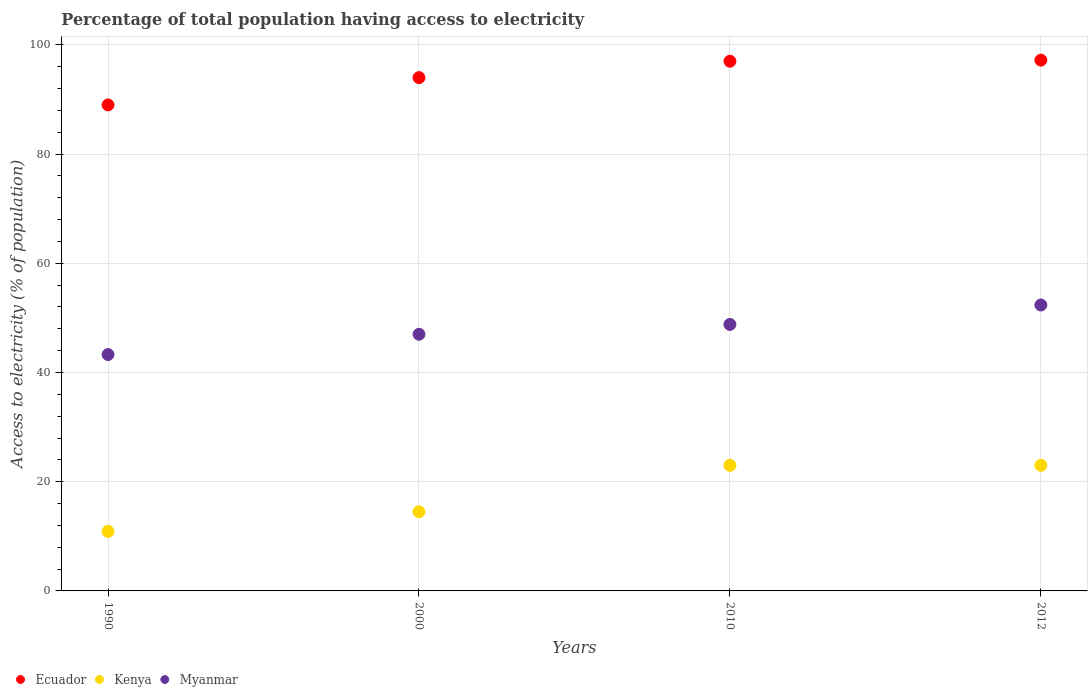How many different coloured dotlines are there?
Your response must be concise. 3. Is the number of dotlines equal to the number of legend labels?
Keep it short and to the point. Yes. What is the percentage of population that have access to electricity in Kenya in 2010?
Your answer should be compact. 23. Across all years, what is the maximum percentage of population that have access to electricity in Ecuador?
Provide a succinct answer. 97.2. Across all years, what is the minimum percentage of population that have access to electricity in Myanmar?
Give a very brief answer. 43.29. In which year was the percentage of population that have access to electricity in Myanmar minimum?
Provide a short and direct response. 1990. What is the total percentage of population that have access to electricity in Kenya in the graph?
Ensure brevity in your answer.  71.4. What is the difference between the percentage of population that have access to electricity in Myanmar in 1990 and that in 2000?
Your answer should be compact. -3.71. What is the difference between the percentage of population that have access to electricity in Ecuador in 2000 and the percentage of population that have access to electricity in Kenya in 1990?
Your response must be concise. 83.1. What is the average percentage of population that have access to electricity in Ecuador per year?
Offer a terse response. 94.3. In the year 2010, what is the difference between the percentage of population that have access to electricity in Kenya and percentage of population that have access to electricity in Ecuador?
Offer a terse response. -74. What is the ratio of the percentage of population that have access to electricity in Ecuador in 2010 to that in 2012?
Your answer should be compact. 1. Is the percentage of population that have access to electricity in Myanmar in 1990 less than that in 2000?
Keep it short and to the point. Yes. Is the difference between the percentage of population that have access to electricity in Kenya in 2000 and 2012 greater than the difference between the percentage of population that have access to electricity in Ecuador in 2000 and 2012?
Your response must be concise. No. What is the difference between the highest and the second highest percentage of population that have access to electricity in Myanmar?
Offer a very short reply. 3.56. What is the difference between the highest and the lowest percentage of population that have access to electricity in Myanmar?
Offer a very short reply. 9.07. Is the percentage of population that have access to electricity in Myanmar strictly greater than the percentage of population that have access to electricity in Kenya over the years?
Keep it short and to the point. Yes. How many dotlines are there?
Your answer should be compact. 3. How many years are there in the graph?
Give a very brief answer. 4. Are the values on the major ticks of Y-axis written in scientific E-notation?
Give a very brief answer. No. What is the title of the graph?
Provide a succinct answer. Percentage of total population having access to electricity. Does "Grenada" appear as one of the legend labels in the graph?
Offer a very short reply. No. What is the label or title of the X-axis?
Ensure brevity in your answer.  Years. What is the label or title of the Y-axis?
Give a very brief answer. Access to electricity (% of population). What is the Access to electricity (% of population) in Ecuador in 1990?
Provide a short and direct response. 89. What is the Access to electricity (% of population) of Myanmar in 1990?
Ensure brevity in your answer.  43.29. What is the Access to electricity (% of population) of Ecuador in 2000?
Provide a succinct answer. 94. What is the Access to electricity (% of population) in Ecuador in 2010?
Your response must be concise. 97. What is the Access to electricity (% of population) in Kenya in 2010?
Ensure brevity in your answer.  23. What is the Access to electricity (% of population) in Myanmar in 2010?
Make the answer very short. 48.8. What is the Access to electricity (% of population) in Ecuador in 2012?
Offer a terse response. 97.2. What is the Access to electricity (% of population) of Kenya in 2012?
Your answer should be very brief. 23. What is the Access to electricity (% of population) in Myanmar in 2012?
Your answer should be very brief. 52.36. Across all years, what is the maximum Access to electricity (% of population) in Ecuador?
Give a very brief answer. 97.2. Across all years, what is the maximum Access to electricity (% of population) in Myanmar?
Give a very brief answer. 52.36. Across all years, what is the minimum Access to electricity (% of population) in Ecuador?
Offer a very short reply. 89. Across all years, what is the minimum Access to electricity (% of population) in Kenya?
Ensure brevity in your answer.  10.9. Across all years, what is the minimum Access to electricity (% of population) in Myanmar?
Your answer should be compact. 43.29. What is the total Access to electricity (% of population) in Ecuador in the graph?
Keep it short and to the point. 377.2. What is the total Access to electricity (% of population) in Kenya in the graph?
Give a very brief answer. 71.4. What is the total Access to electricity (% of population) of Myanmar in the graph?
Your response must be concise. 191.45. What is the difference between the Access to electricity (% of population) in Myanmar in 1990 and that in 2000?
Keep it short and to the point. -3.71. What is the difference between the Access to electricity (% of population) in Ecuador in 1990 and that in 2010?
Your response must be concise. -8. What is the difference between the Access to electricity (% of population) in Kenya in 1990 and that in 2010?
Your response must be concise. -12.1. What is the difference between the Access to electricity (% of population) in Myanmar in 1990 and that in 2010?
Your answer should be very brief. -5.51. What is the difference between the Access to electricity (% of population) of Ecuador in 1990 and that in 2012?
Offer a terse response. -8.2. What is the difference between the Access to electricity (% of population) of Myanmar in 1990 and that in 2012?
Ensure brevity in your answer.  -9.07. What is the difference between the Access to electricity (% of population) of Ecuador in 2000 and that in 2012?
Provide a succinct answer. -3.2. What is the difference between the Access to electricity (% of population) in Myanmar in 2000 and that in 2012?
Provide a succinct answer. -5.36. What is the difference between the Access to electricity (% of population) of Kenya in 2010 and that in 2012?
Your answer should be very brief. 0. What is the difference between the Access to electricity (% of population) in Myanmar in 2010 and that in 2012?
Provide a succinct answer. -3.56. What is the difference between the Access to electricity (% of population) of Ecuador in 1990 and the Access to electricity (% of population) of Kenya in 2000?
Your response must be concise. 74.5. What is the difference between the Access to electricity (% of population) in Ecuador in 1990 and the Access to electricity (% of population) in Myanmar in 2000?
Your answer should be very brief. 42. What is the difference between the Access to electricity (% of population) in Kenya in 1990 and the Access to electricity (% of population) in Myanmar in 2000?
Keep it short and to the point. -36.1. What is the difference between the Access to electricity (% of population) in Ecuador in 1990 and the Access to electricity (% of population) in Myanmar in 2010?
Keep it short and to the point. 40.2. What is the difference between the Access to electricity (% of population) of Kenya in 1990 and the Access to electricity (% of population) of Myanmar in 2010?
Give a very brief answer. -37.9. What is the difference between the Access to electricity (% of population) in Ecuador in 1990 and the Access to electricity (% of population) in Myanmar in 2012?
Ensure brevity in your answer.  36.64. What is the difference between the Access to electricity (% of population) of Kenya in 1990 and the Access to electricity (% of population) of Myanmar in 2012?
Your answer should be compact. -41.46. What is the difference between the Access to electricity (% of population) in Ecuador in 2000 and the Access to electricity (% of population) in Kenya in 2010?
Your answer should be compact. 71. What is the difference between the Access to electricity (% of population) in Ecuador in 2000 and the Access to electricity (% of population) in Myanmar in 2010?
Provide a succinct answer. 45.2. What is the difference between the Access to electricity (% of population) in Kenya in 2000 and the Access to electricity (% of population) in Myanmar in 2010?
Offer a terse response. -34.3. What is the difference between the Access to electricity (% of population) in Ecuador in 2000 and the Access to electricity (% of population) in Myanmar in 2012?
Provide a short and direct response. 41.64. What is the difference between the Access to electricity (% of population) in Kenya in 2000 and the Access to electricity (% of population) in Myanmar in 2012?
Your answer should be compact. -37.86. What is the difference between the Access to electricity (% of population) in Ecuador in 2010 and the Access to electricity (% of population) in Kenya in 2012?
Ensure brevity in your answer.  74. What is the difference between the Access to electricity (% of population) in Ecuador in 2010 and the Access to electricity (% of population) in Myanmar in 2012?
Provide a succinct answer. 44.64. What is the difference between the Access to electricity (% of population) of Kenya in 2010 and the Access to electricity (% of population) of Myanmar in 2012?
Offer a very short reply. -29.36. What is the average Access to electricity (% of population) in Ecuador per year?
Make the answer very short. 94.3. What is the average Access to electricity (% of population) of Kenya per year?
Your response must be concise. 17.85. What is the average Access to electricity (% of population) in Myanmar per year?
Provide a short and direct response. 47.86. In the year 1990, what is the difference between the Access to electricity (% of population) in Ecuador and Access to electricity (% of population) in Kenya?
Provide a short and direct response. 78.1. In the year 1990, what is the difference between the Access to electricity (% of population) in Ecuador and Access to electricity (% of population) in Myanmar?
Provide a short and direct response. 45.71. In the year 1990, what is the difference between the Access to electricity (% of population) of Kenya and Access to electricity (% of population) of Myanmar?
Provide a succinct answer. -32.39. In the year 2000, what is the difference between the Access to electricity (% of population) of Ecuador and Access to electricity (% of population) of Kenya?
Offer a terse response. 79.5. In the year 2000, what is the difference between the Access to electricity (% of population) of Kenya and Access to electricity (% of population) of Myanmar?
Ensure brevity in your answer.  -32.5. In the year 2010, what is the difference between the Access to electricity (% of population) of Ecuador and Access to electricity (% of population) of Kenya?
Your answer should be very brief. 74. In the year 2010, what is the difference between the Access to electricity (% of population) of Ecuador and Access to electricity (% of population) of Myanmar?
Your answer should be very brief. 48.2. In the year 2010, what is the difference between the Access to electricity (% of population) in Kenya and Access to electricity (% of population) in Myanmar?
Your answer should be very brief. -25.8. In the year 2012, what is the difference between the Access to electricity (% of population) of Ecuador and Access to electricity (% of population) of Kenya?
Make the answer very short. 74.2. In the year 2012, what is the difference between the Access to electricity (% of population) of Ecuador and Access to electricity (% of population) of Myanmar?
Your answer should be compact. 44.84. In the year 2012, what is the difference between the Access to electricity (% of population) in Kenya and Access to electricity (% of population) in Myanmar?
Provide a succinct answer. -29.36. What is the ratio of the Access to electricity (% of population) in Ecuador in 1990 to that in 2000?
Give a very brief answer. 0.95. What is the ratio of the Access to electricity (% of population) of Kenya in 1990 to that in 2000?
Your answer should be very brief. 0.75. What is the ratio of the Access to electricity (% of population) of Myanmar in 1990 to that in 2000?
Keep it short and to the point. 0.92. What is the ratio of the Access to electricity (% of population) of Ecuador in 1990 to that in 2010?
Give a very brief answer. 0.92. What is the ratio of the Access to electricity (% of population) in Kenya in 1990 to that in 2010?
Make the answer very short. 0.47. What is the ratio of the Access to electricity (% of population) in Myanmar in 1990 to that in 2010?
Offer a terse response. 0.89. What is the ratio of the Access to electricity (% of population) in Ecuador in 1990 to that in 2012?
Your answer should be compact. 0.92. What is the ratio of the Access to electricity (% of population) in Kenya in 1990 to that in 2012?
Give a very brief answer. 0.47. What is the ratio of the Access to electricity (% of population) of Myanmar in 1990 to that in 2012?
Offer a very short reply. 0.83. What is the ratio of the Access to electricity (% of population) in Ecuador in 2000 to that in 2010?
Your response must be concise. 0.97. What is the ratio of the Access to electricity (% of population) of Kenya in 2000 to that in 2010?
Provide a succinct answer. 0.63. What is the ratio of the Access to electricity (% of population) in Myanmar in 2000 to that in 2010?
Give a very brief answer. 0.96. What is the ratio of the Access to electricity (% of population) in Ecuador in 2000 to that in 2012?
Offer a very short reply. 0.97. What is the ratio of the Access to electricity (% of population) of Kenya in 2000 to that in 2012?
Offer a very short reply. 0.63. What is the ratio of the Access to electricity (% of population) of Myanmar in 2000 to that in 2012?
Provide a short and direct response. 0.9. What is the ratio of the Access to electricity (% of population) in Myanmar in 2010 to that in 2012?
Offer a terse response. 0.93. What is the difference between the highest and the second highest Access to electricity (% of population) of Ecuador?
Make the answer very short. 0.2. What is the difference between the highest and the second highest Access to electricity (% of population) of Myanmar?
Provide a succinct answer. 3.56. What is the difference between the highest and the lowest Access to electricity (% of population) of Ecuador?
Offer a very short reply. 8.2. What is the difference between the highest and the lowest Access to electricity (% of population) in Kenya?
Your answer should be compact. 12.1. What is the difference between the highest and the lowest Access to electricity (% of population) of Myanmar?
Your answer should be compact. 9.07. 